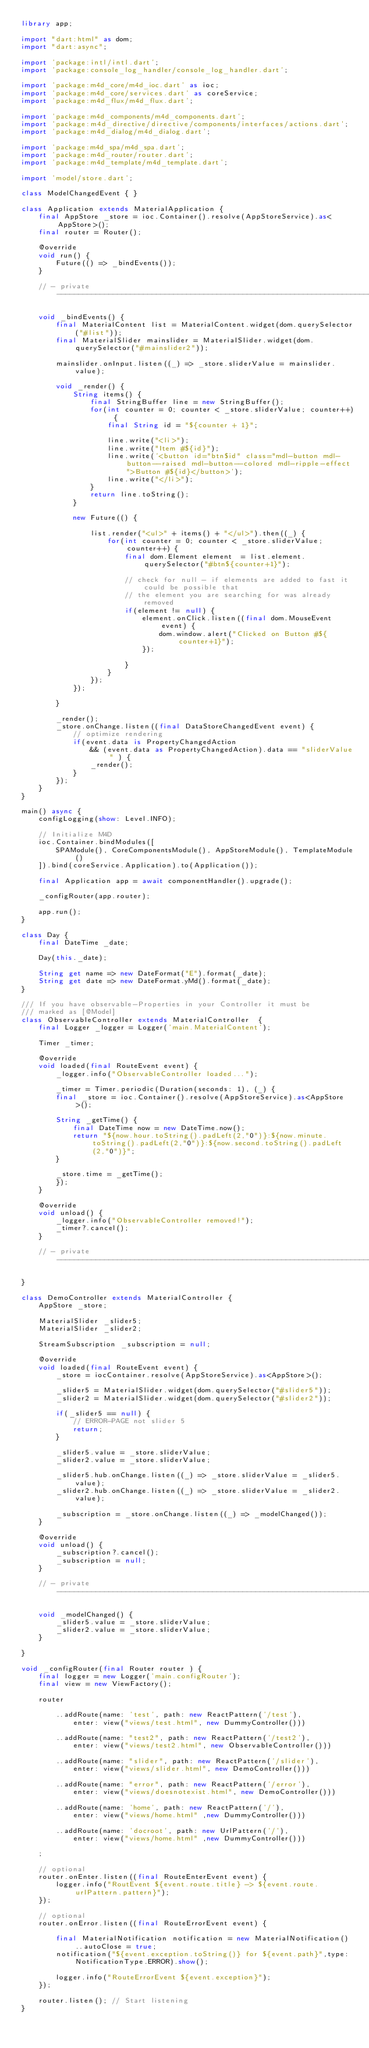<code> <loc_0><loc_0><loc_500><loc_500><_Dart_>library app;

import "dart:html" as dom;
import "dart:async";

import 'package:intl/intl.dart';
import 'package:console_log_handler/console_log_handler.dart';

import 'package:m4d_core/m4d_ioc.dart' as ioc;
import 'package:m4d_core/services.dart' as coreService;
import 'package:m4d_flux/m4d_flux.dart';

import 'package:m4d_components/m4d_components.dart';
import 'package:m4d_directive/directive/components/interfaces/actions.dart';
import 'package:m4d_dialog/m4d_dialog.dart';

import 'package:m4d_spa/m4d_spa.dart';
import 'package:m4d_router/router.dart';
import 'package:m4d_template/m4d_template.dart';

import 'model/store.dart';

class ModelChangedEvent { }

class Application extends MaterialApplication {
    final AppStore _store = ioc.Container().resolve(AppStoreService).as<AppStore>();
    final router = Router();

    @override
    void run() {
        Future(() => _bindEvents());
    }

    // - private -----------------------------------------------------------------------------------

    void _bindEvents() {
        final MaterialContent list = MaterialContent.widget(dom.querySelector("#list"));
        final MaterialSlider mainslider = MaterialSlider.widget(dom.querySelector("#mainslider2"));

        mainslider.onInput.listen((_) => _store.sliderValue = mainslider.value);

        void _render() {
            String items() {
                final StringBuffer line = new StringBuffer();
                for(int counter = 0; counter < _store.sliderValue; counter++) {
                    final String id = "${counter + 1}";

                    line.write("<li>");
                    line.write("Item #${id}");
                    line.write('<button id="btn$id" class="mdl-button mdl-button--raised mdl-button--colored mdl-ripple-effect">Button #${id}</button>');
                    line.write("</li>");
                }
                return line.toString();
            }

            new Future(() {

                list.render("<ul>" + items() + "</ul>").then((_) {
                    for(int counter = 0; counter < _store.sliderValue; counter++) {
                        final dom.Element element  = list.element.querySelector("#btn${counter+1}");

                        // check for null - if elements are added to fast it could be possible that
                        // the element you are searching for was already removed
                        if(element != null) {
                            element.onClick.listen((final dom.MouseEvent event) {
                                dom.window.alert("Clicked on Button #${counter+1}");
                            });

                        }
                    }
                });
            });

        }
        
        _render();
        _store.onChange.listen((final DataStoreChangedEvent event) {
            // optimize rendering
            if(event.data is PropertyChangedAction
                && (event.data as PropertyChangedAction).data == "sliderValue" ) {
                _render();
            }
        });
    }
}

main() async {
    configLogging(show: Level.INFO);

    // Initialize M4D
    ioc.Container.bindModules([
        SPAModule(), CoreComponentsModule(), AppStoreModule(), TemplateModule()
    ]).bind(coreService.Application).to(Application());

    final Application app = await componentHandler().upgrade();

    _configRouter(app.router);

    app.run();
}

class Day {
    final DateTime _date;

    Day(this._date);

    String get name => new DateFormat("E").format(_date);
    String get date => new DateFormat.yMd().format(_date);
}

/// If you have observable-Properties in your Controller it must be
/// marked as [@Model]
class ObservableController extends MaterialController  {
    final Logger _logger = Logger('main.MaterialContent');

    Timer _timer;

    @override
    void loaded(final RouteEvent event) {
        _logger.info("ObservableController loaded...");

        _timer = Timer.periodic(Duration(seconds: 1), (_) {
        final _store = ioc.Container().resolve(AppStoreService).as<AppStore>();

        String _getTime() {
            final DateTime now = new DateTime.now();
            return "${now.hour.toString().padLeft(2,"0")}:${now.minute.toString().padLeft(2,"0")}:${now.second.toString().padLeft(2,"0")}";
        }

        _store.time = _getTime();
        });
    }

    @override
    void unload() {
        _logger.info("ObservableController removed!");
        _timer?.cancel();
    }
    
    // - private ------------------------------------------------------------------------------------------------------

}

class DemoController extends MaterialController {
    AppStore _store;

    MaterialSlider _slider5;
    MaterialSlider _slider2;

    StreamSubscription _subscription = null;

    @override
    void loaded(final RouteEvent event) {
        _store = iocContainer.resolve(AppStoreService).as<AppStore>();

        _slider5 = MaterialSlider.widget(dom.querySelector("#slider5"));
        _slider2 = MaterialSlider.widget(dom.querySelector("#slider2"));

        if(_slider5 == null) {
            // ERROR-PAGE not slider 5
            return;
        }

        _slider5.value = _store.sliderValue;
        _slider2.value = _store.sliderValue;

        _slider5.hub.onChange.listen((_) => _store.sliderValue = _slider5.value);
        _slider2.hub.onChange.listen((_) => _store.sliderValue = _slider2.value);

        _subscription = _store.onChange.listen((_) => _modelChanged());
    }

    @override
    void unload() {
        _subscription?.cancel();
        _subscription = null;
    }

    // - private ------------------------------------------------------------------------------------------------------

    void _modelChanged() {
        _slider5.value = _store.sliderValue;
        _slider2.value = _store.sliderValue;
    }

}

void _configRouter(final Router router ) {
    final logger = new Logger('main.configRouter');
    final view = new ViewFactory();

    router
    
        ..addRoute(name: 'test', path: new ReactPattern('/test'),
            enter: view("views/test.html", new DummyController()))

        ..addRoute(name: "test2", path: new ReactPattern('/test2'),
            enter: view("views/test2.html", new ObservableController()))

        ..addRoute(name: "slider", path: new ReactPattern('/slider'),
            enter: view("views/slider.html", new DemoController()))

        ..addRoute(name: "error", path: new ReactPattern('/error'),
            enter: view("views/doesnotexist.html", new DemoController()))

        ..addRoute(name: 'home', path: new ReactPattern('/'),
            enter: view("views/home.html" ,new DummyController()))

        ..addRoute(name: 'docroot', path: new UrlPattern('/'),
            enter: view("views/home.html" ,new DummyController()))

    ;

    // optional
    router.onEnter.listen((final RouteEnterEvent event) {
        logger.info("RoutEvent ${event.route.title} -> ${event.route.urlPattern.pattern}");
    });

    // optional
    router.onError.listen((final RouteErrorEvent event) {
        
        final MaterialNotification notification = new MaterialNotification()..autoClose = true;
        notification("${event.exception.toString()} for ${event.path}",type: NotificationType.ERROR).show();

        logger.info("RouteErrorEvent ${event.exception}");
    });

    router.listen(); // Start listening
}

</code> 